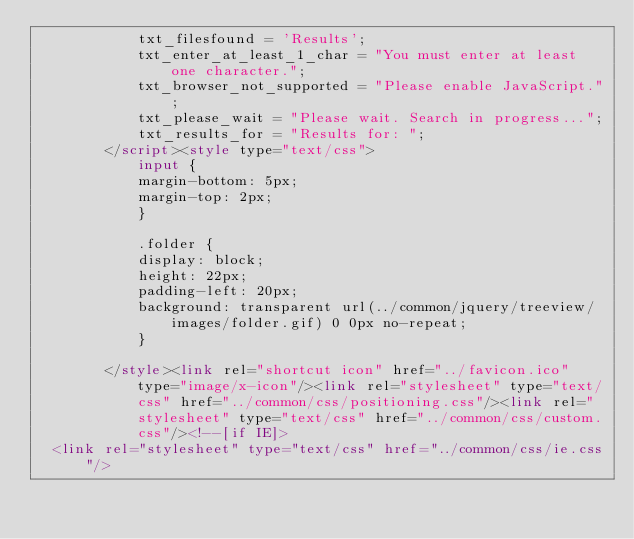Convert code to text. <code><loc_0><loc_0><loc_500><loc_500><_HTML_>            txt_filesfound = 'Results';
            txt_enter_at_least_1_char = "You must enter at least one character.";
            txt_browser_not_supported = "Please enable JavaScript.";
            txt_please_wait = "Please wait. Search in progress...";
            txt_results_for = "Results for: ";
        </script><style type="text/css">
            input {
            margin-bottom: 5px;
            margin-top: 2px;
            }

            .folder {
            display: block;
            height: 22px;
            padding-left: 20px;
            background: transparent url(../common/jquery/treeview/images/folder.gif) 0 0px no-repeat;
            }
            
        </style><link rel="shortcut icon" href="../favicon.ico" type="image/x-icon"/><link rel="stylesheet" type="text/css" href="../common/css/positioning.css"/><link rel="stylesheet" type="text/css" href="../common/css/custom.css"/><!--[if IE]>
	<link rel="stylesheet" type="text/css" href="../common/css/ie.css"/></code> 